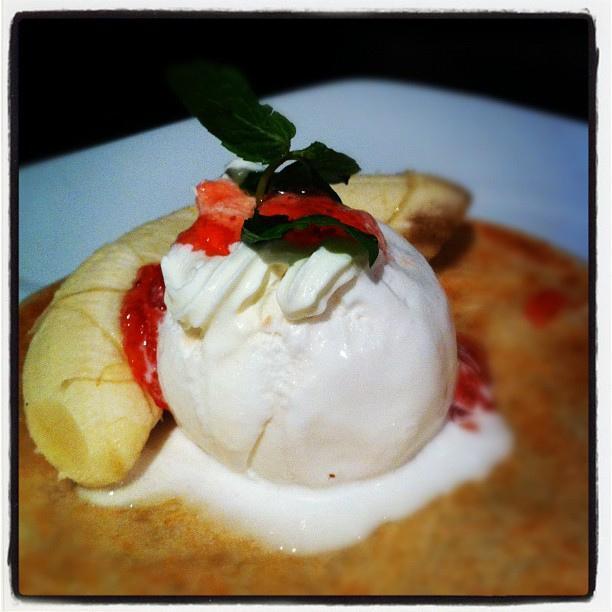How many umbrellas are visible in this photo?
Give a very brief answer. 0. 